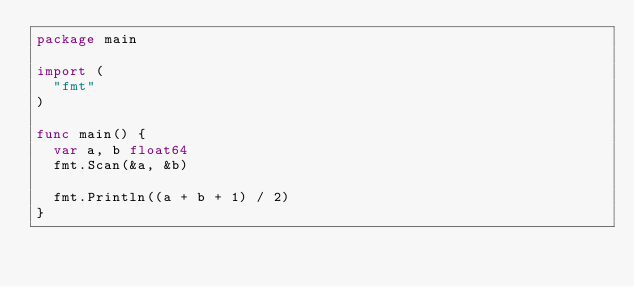<code> <loc_0><loc_0><loc_500><loc_500><_Go_>package main

import (
	"fmt"
)

func main() {
	var a, b float64
	fmt.Scan(&a, &b)

	fmt.Println((a + b + 1) / 2)
}
</code> 